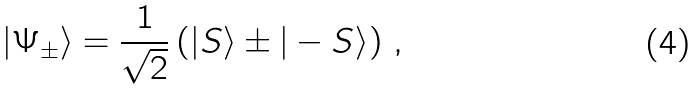<formula> <loc_0><loc_0><loc_500><loc_500>| \Psi _ { \pm } \rangle = \frac { 1 } { \sqrt { 2 } } \left ( | S \rangle \pm | - S \rangle \right ) \, ,</formula> 